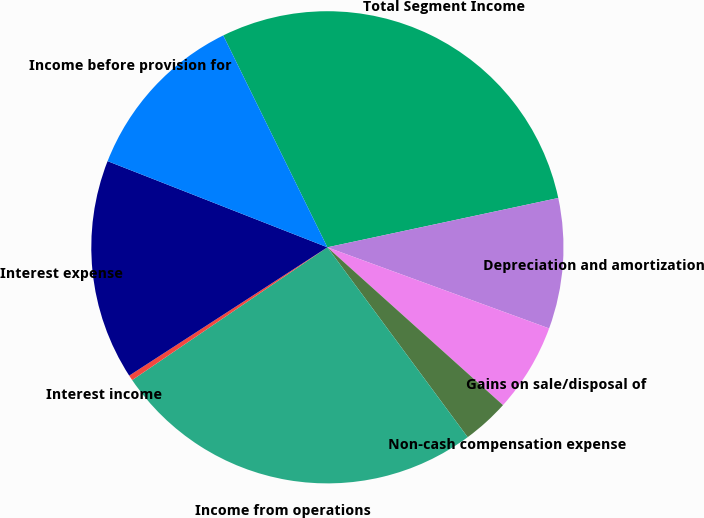<chart> <loc_0><loc_0><loc_500><loc_500><pie_chart><fcel>Total Segment Income<fcel>Depreciation and amortization<fcel>Gains on sale/disposal of<fcel>Non-cash compensation expense<fcel>Income from operations<fcel>Interest income<fcel>Interest expense<fcel>Income before provision for<nl><fcel>28.92%<fcel>8.93%<fcel>6.07%<fcel>3.22%<fcel>25.62%<fcel>0.36%<fcel>15.09%<fcel>11.78%<nl></chart> 